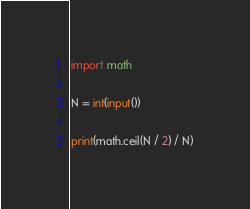Convert code to text. <code><loc_0><loc_0><loc_500><loc_500><_Python_>import math

N = int(input())

print(math.ceil(N / 2) / N)
</code> 